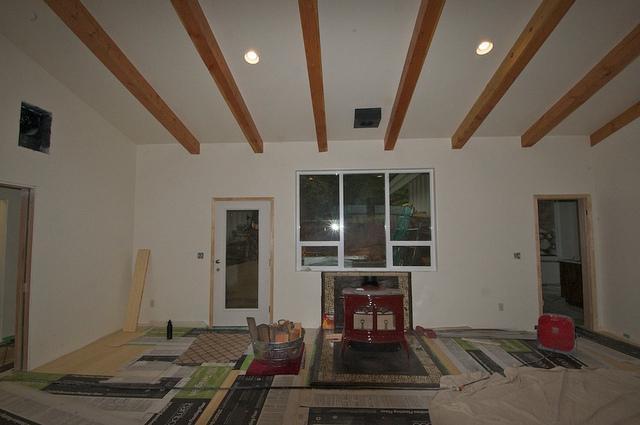How many of the motorcycles are blue?
Give a very brief answer. 0. 